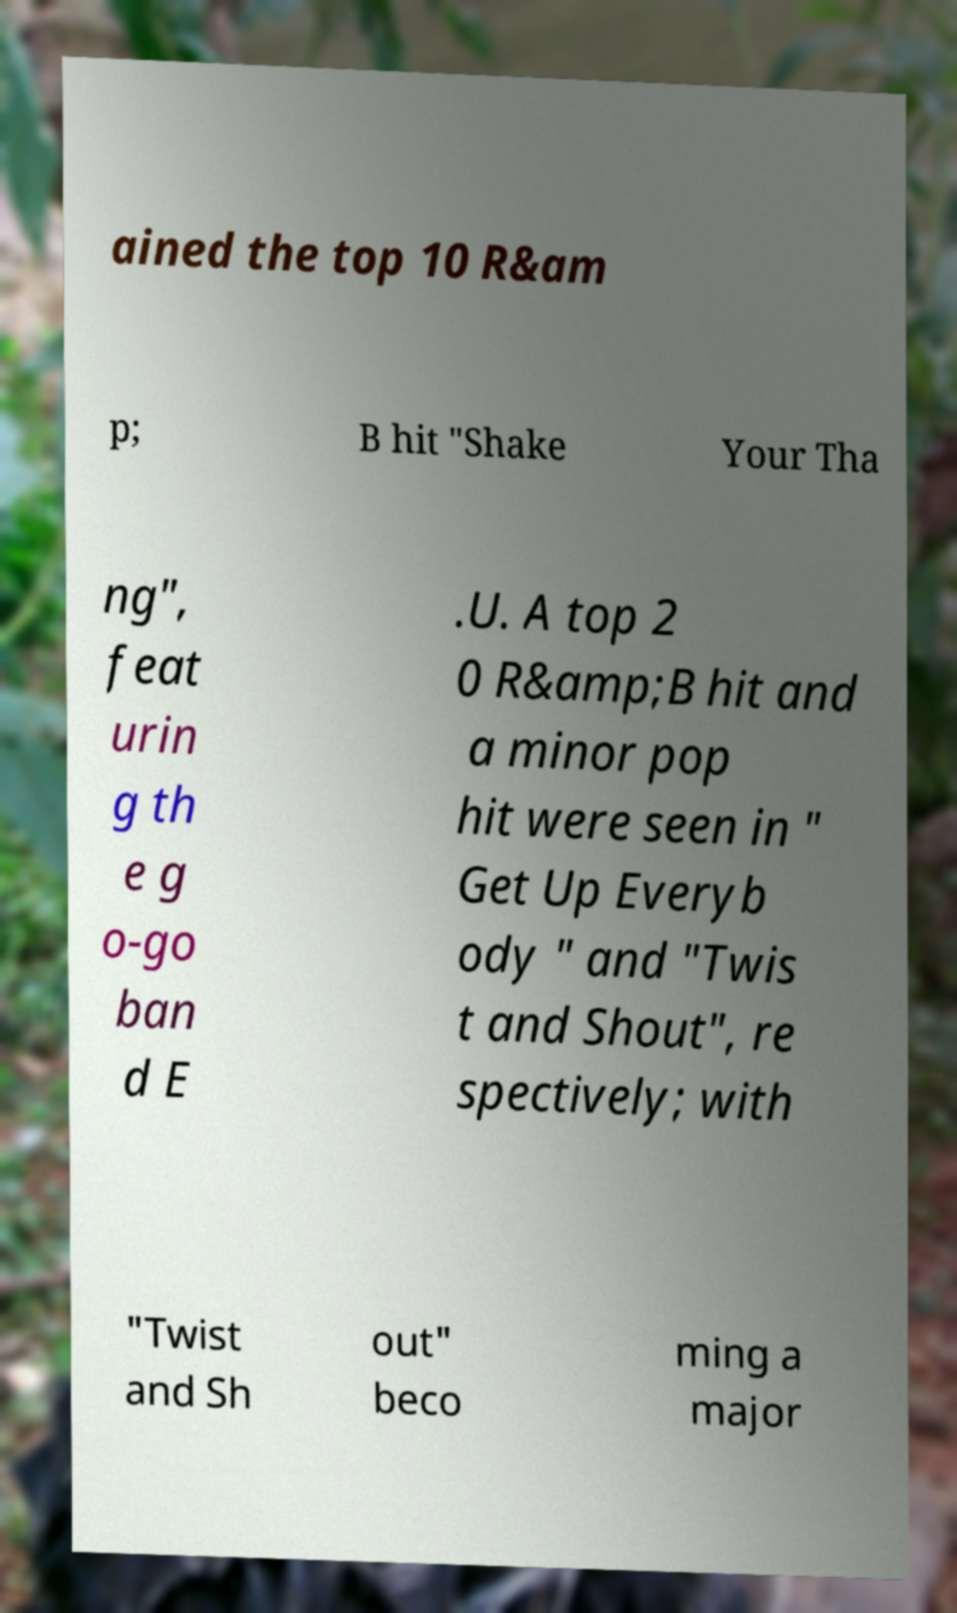Can you read and provide the text displayed in the image?This photo seems to have some interesting text. Can you extract and type it out for me? ained the top 10 R&am p; B hit "Shake Your Tha ng", feat urin g th e g o-go ban d E .U. A top 2 0 R&amp;B hit and a minor pop hit were seen in " Get Up Everyb ody " and "Twis t and Shout", re spectively; with "Twist and Sh out" beco ming a major 